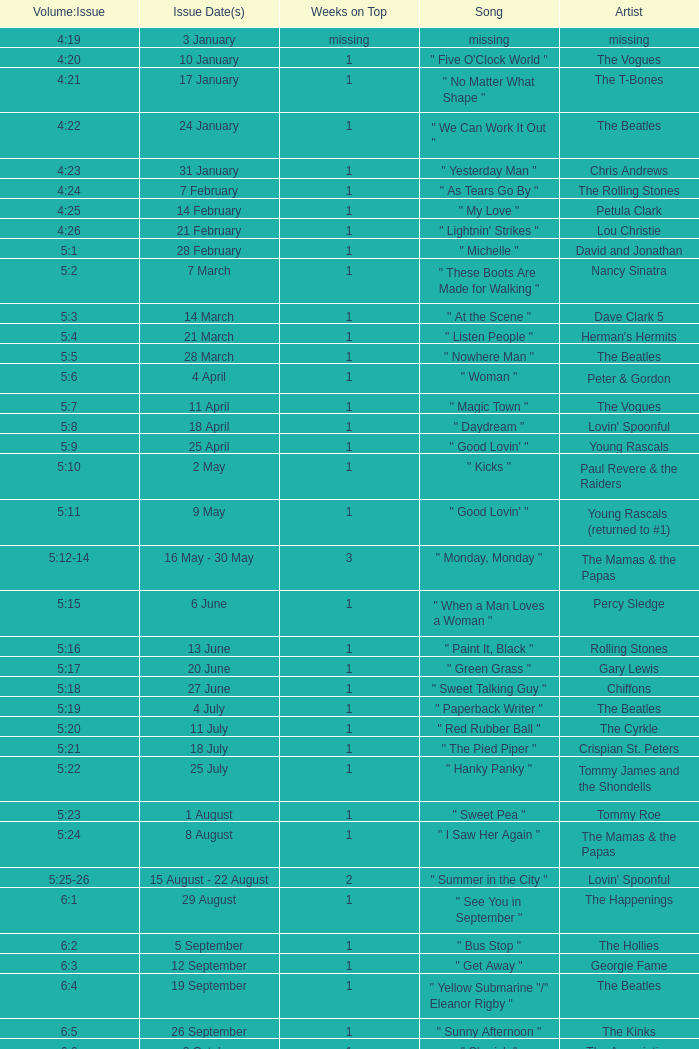Could you parse the entire table as a dict? {'header': ['Volume:Issue', 'Issue Date(s)', 'Weeks on Top', 'Song', 'Artist'], 'rows': [['4:19', '3 January', 'missing', 'missing', 'missing'], ['4:20', '10 January', '1', '" Five O\'Clock World "', 'The Vogues'], ['4:21', '17 January', '1', '" No Matter What Shape "', 'The T-Bones'], ['4:22', '24 January', '1', '" We Can Work It Out "', 'The Beatles'], ['4:23', '31 January', '1', '" Yesterday Man "', 'Chris Andrews'], ['4:24', '7 February', '1', '" As Tears Go By "', 'The Rolling Stones'], ['4:25', '14 February', '1', '" My Love "', 'Petula Clark'], ['4:26', '21 February', '1', '" Lightnin\' Strikes "', 'Lou Christie'], ['5:1', '28 February', '1', '" Michelle "', 'David and Jonathan'], ['5:2', '7 March', '1', '" These Boots Are Made for Walking "', 'Nancy Sinatra'], ['5:3', '14 March', '1', '" At the Scene "', 'Dave Clark 5'], ['5:4', '21 March', '1', '" Listen People "', "Herman's Hermits"], ['5:5', '28 March', '1', '" Nowhere Man "', 'The Beatles'], ['5:6', '4 April', '1', '" Woman "', 'Peter & Gordon'], ['5:7', '11 April', '1', '" Magic Town "', 'The Vogues'], ['5:8', '18 April', '1', '" Daydream "', "Lovin' Spoonful"], ['5:9', '25 April', '1', '" Good Lovin\' "', 'Young Rascals'], ['5:10', '2 May', '1', '" Kicks "', 'Paul Revere & the Raiders'], ['5:11', '9 May', '1', '" Good Lovin\' "', 'Young Rascals (returned to #1)'], ['5:12-14', '16 May - 30 May', '3', '" Monday, Monday "', 'The Mamas & the Papas'], ['5:15', '6 June', '1', '" When a Man Loves a Woman "', 'Percy Sledge'], ['5:16', '13 June', '1', '" Paint It, Black "', 'Rolling Stones'], ['5:17', '20 June', '1', '" Green Grass "', 'Gary Lewis'], ['5:18', '27 June', '1', '" Sweet Talking Guy "', 'Chiffons'], ['5:19', '4 July', '1', '" Paperback Writer "', 'The Beatles'], ['5:20', '11 July', '1', '" Red Rubber Ball "', 'The Cyrkle'], ['5:21', '18 July', '1', '" The Pied Piper "', 'Crispian St. Peters'], ['5:22', '25 July', '1', '" Hanky Panky "', 'Tommy James and the Shondells'], ['5:23', '1 August', '1', '" Sweet Pea "', 'Tommy Roe'], ['5:24', '8 August', '1', '" I Saw Her Again "', 'The Mamas & the Papas'], ['5:25-26', '15 August - 22 August', '2', '" Summer in the City "', "Lovin' Spoonful"], ['6:1', '29 August', '1', '" See You in September "', 'The Happenings'], ['6:2', '5 September', '1', '" Bus Stop "', 'The Hollies'], ['6:3', '12 September', '1', '" Get Away "', 'Georgie Fame'], ['6:4', '19 September', '1', '" Yellow Submarine "/" Eleanor Rigby "', 'The Beatles'], ['6:5', '26 September', '1', '" Sunny Afternoon "', 'The Kinks'], ['6:6', '3 October', '1', '" Cherish "', 'The Association'], ['6:7', '10 October', '1', '" Black Is Black "', 'Los Bravos'], ['6:8-9', '17 October - 24 October', '2', '" See See Rider "', 'Eric Burdon and The Animals'], ['6:10', '31 October', '1', '" 96 Tears "', 'Question Mark & the Mysterians'], ['6:11', '7 November', '1', '" Last Train to Clarksville "', 'The Monkees'], ['6:12', '14 November', '1', '" Dandy "', "Herman's Hermits"], ['6:13', '21 November', '1', '" Poor Side of Town "', 'Johnny Rivers'], ['6:14-15', '28 November - 5 December', '2', '" Winchester Cathedral "', 'New Vaudeville Band'], ['6:16', '12 December', '1', '" Lady Godiva "', 'Peter & Gordon'], ['6:17', '19 December', '1', '" Stop! Stop! Stop! "', 'The Hollies'], ['6:18-19', '26 December - 2 January', '2', '" I\'m a Believer "', 'The Monkees']]} Volume:Issue of 5:16 has what song listed? " Paint It, Black ". 